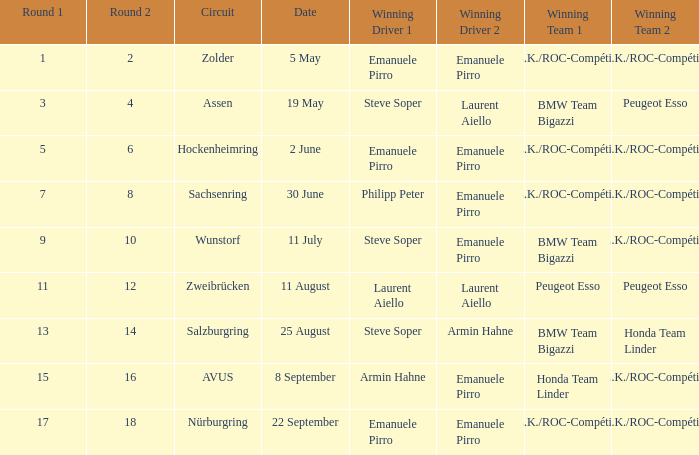What was the winning team on 11 July? BMW Team Bigazzi A.Z.K./ROC-Compétition. 